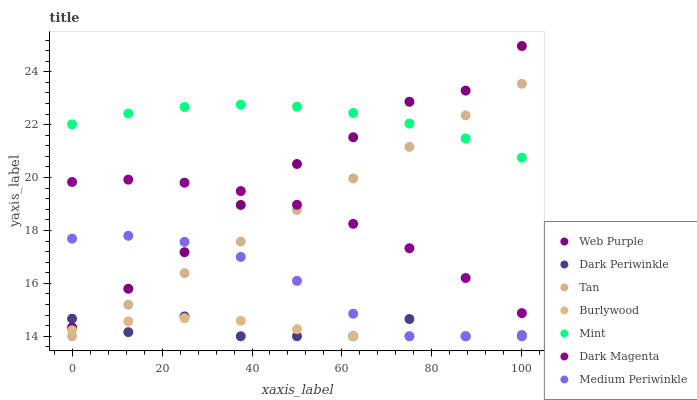Does Dark Periwinkle have the minimum area under the curve?
Answer yes or no. Yes. Does Mint have the maximum area under the curve?
Answer yes or no. Yes. Does Burlywood have the minimum area under the curve?
Answer yes or no. No. Does Burlywood have the maximum area under the curve?
Answer yes or no. No. Is Tan the smoothest?
Answer yes or no. Yes. Is Dark Periwinkle the roughest?
Answer yes or no. Yes. Is Burlywood the smoothest?
Answer yes or no. No. Is Burlywood the roughest?
Answer yes or no. No. Does Burlywood have the lowest value?
Answer yes or no. Yes. Does Web Purple have the lowest value?
Answer yes or no. No. Does Web Purple have the highest value?
Answer yes or no. Yes. Does Medium Periwinkle have the highest value?
Answer yes or no. No. Is Tan less than Web Purple?
Answer yes or no. Yes. Is Web Purple greater than Tan?
Answer yes or no. Yes. Does Tan intersect Burlywood?
Answer yes or no. Yes. Is Tan less than Burlywood?
Answer yes or no. No. Is Tan greater than Burlywood?
Answer yes or no. No. Does Tan intersect Web Purple?
Answer yes or no. No. 